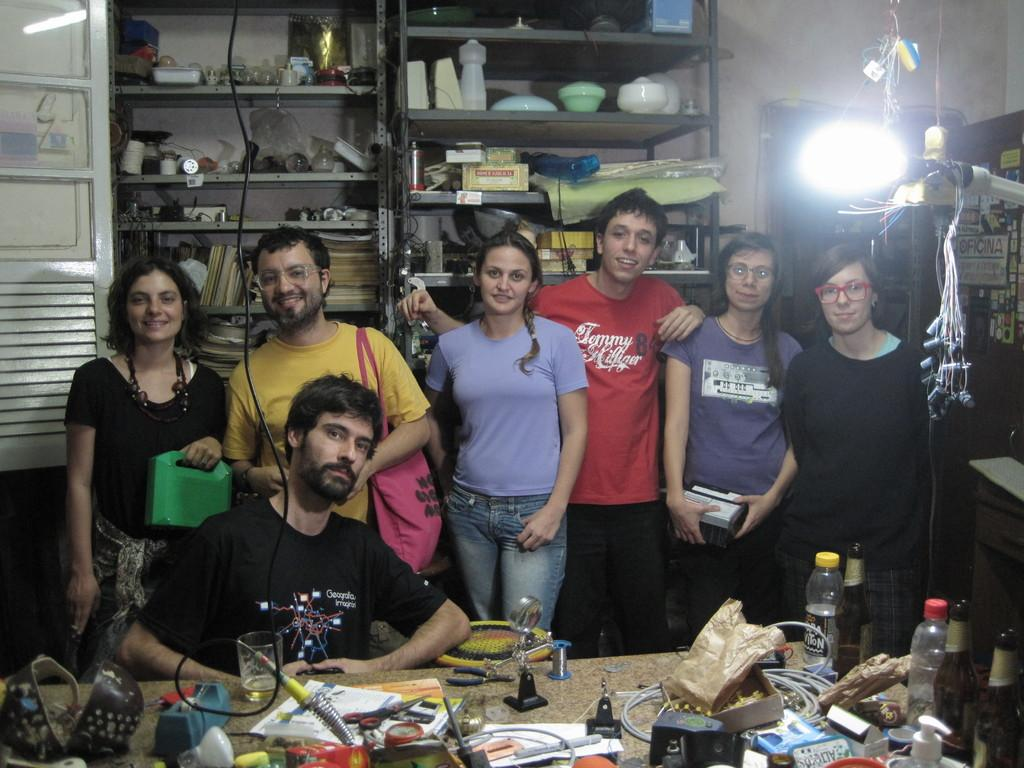What is happening with the people in the image? There are people standing in the image. What can be seen on the shelf in the image? There is a shelf with objects in the image. What is on the table in the image? There is a bottle, a glass, a cover, and other objects on the table. What is the source of light in the image? There is a light in the image. What is connected to the light in the image? There is a cable in the image. Can you see a snail crawling on the table in the image? There is no snail present in the image. 